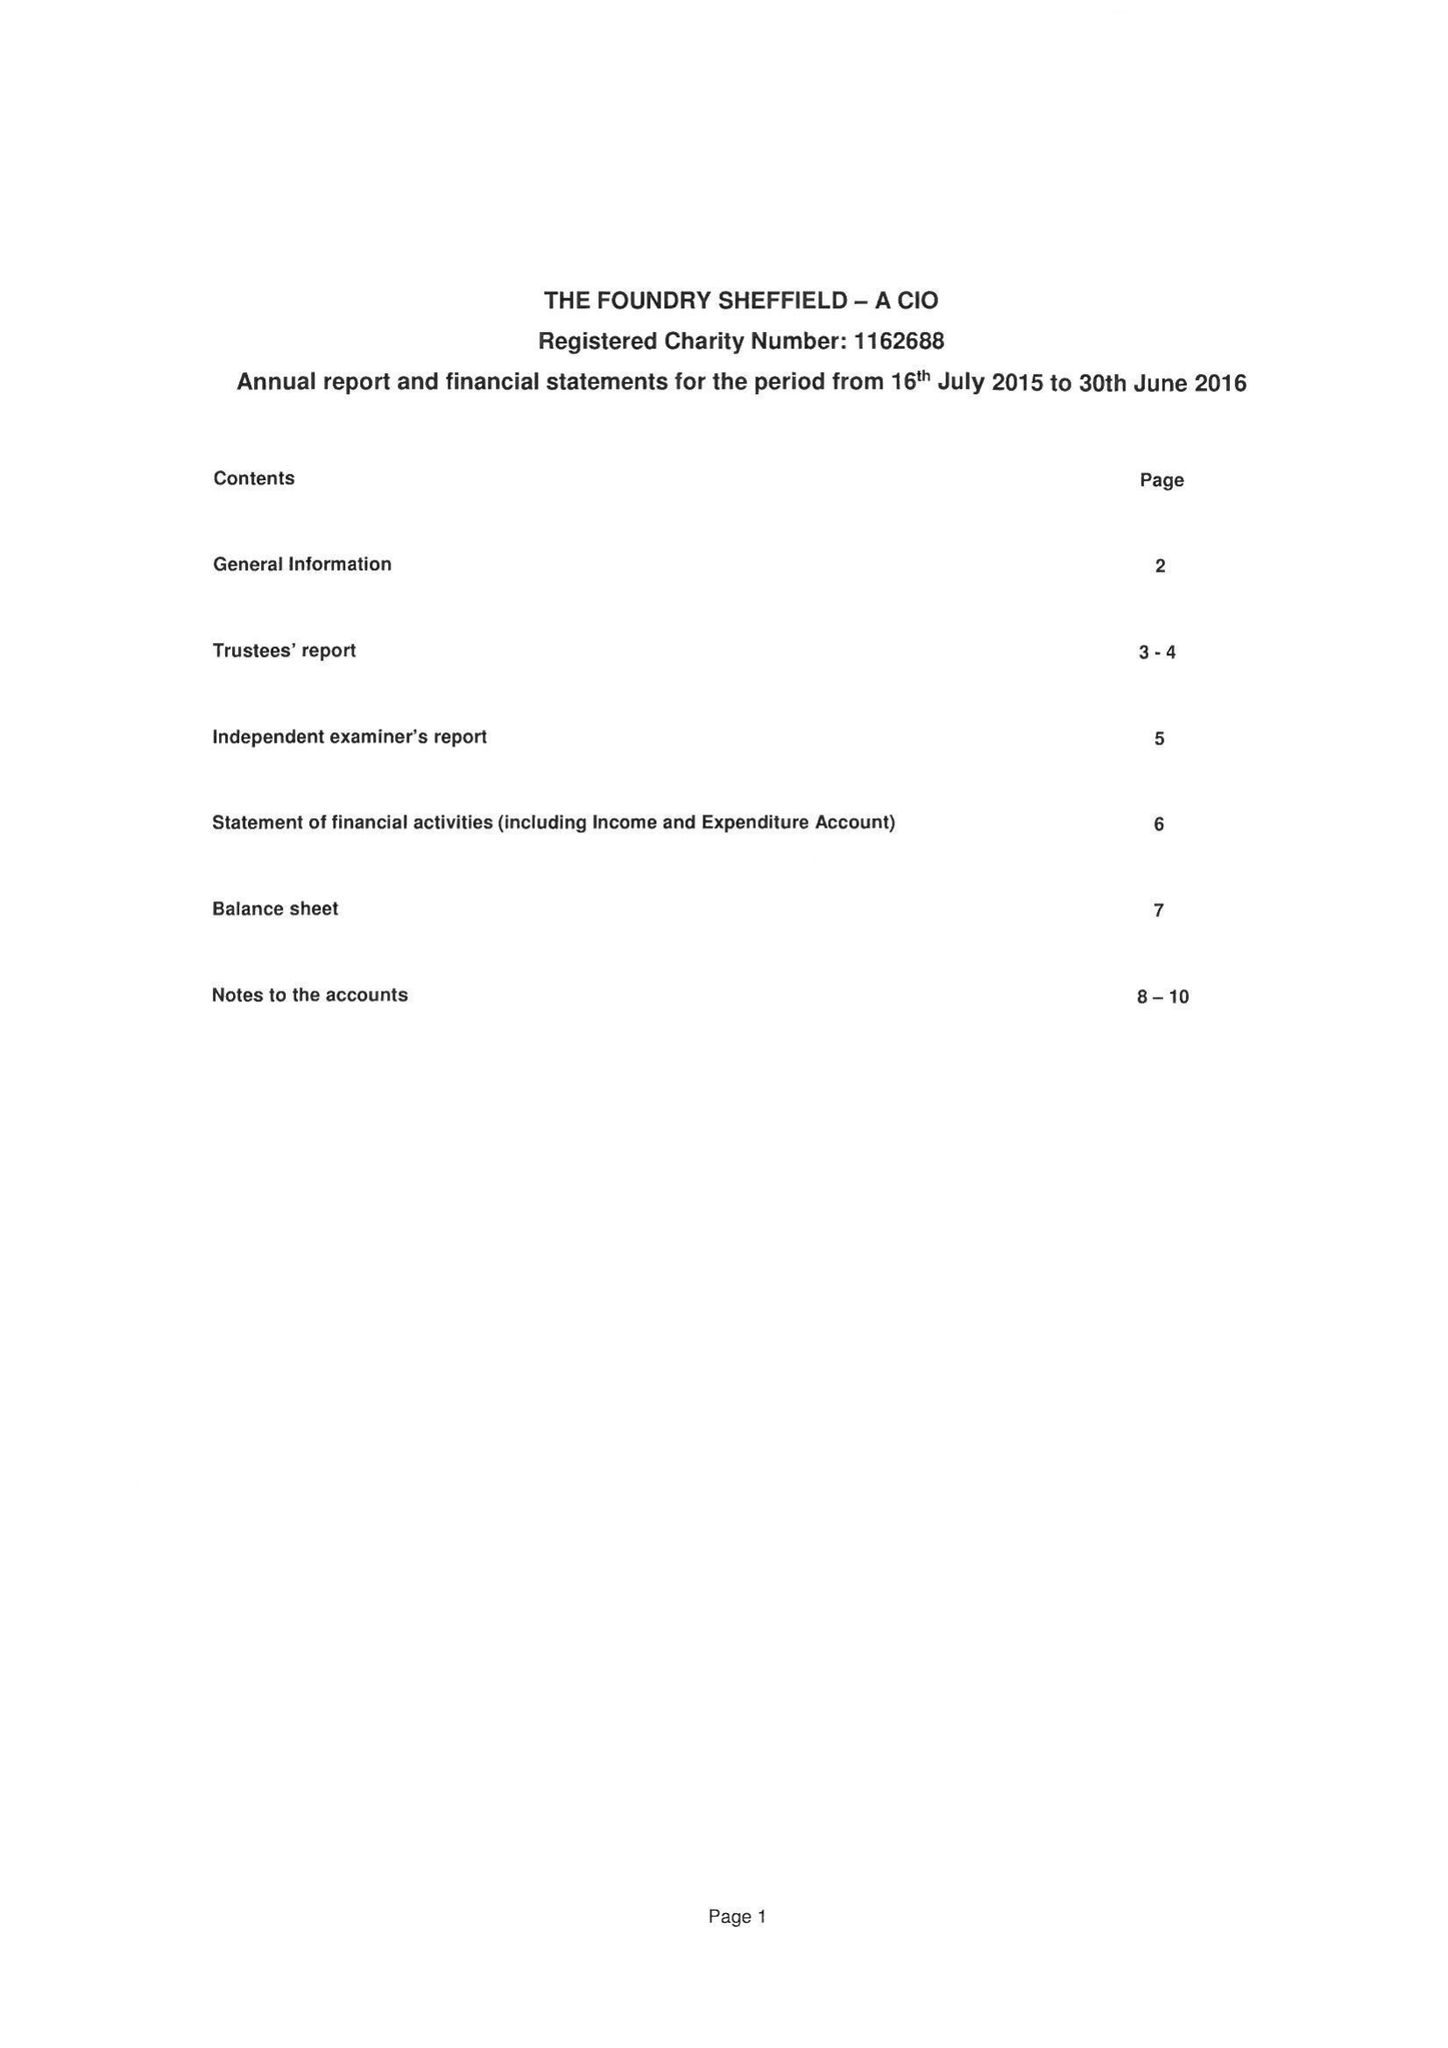What is the value for the address__postcode?
Answer the question using a single word or phrase. S1 2JB 